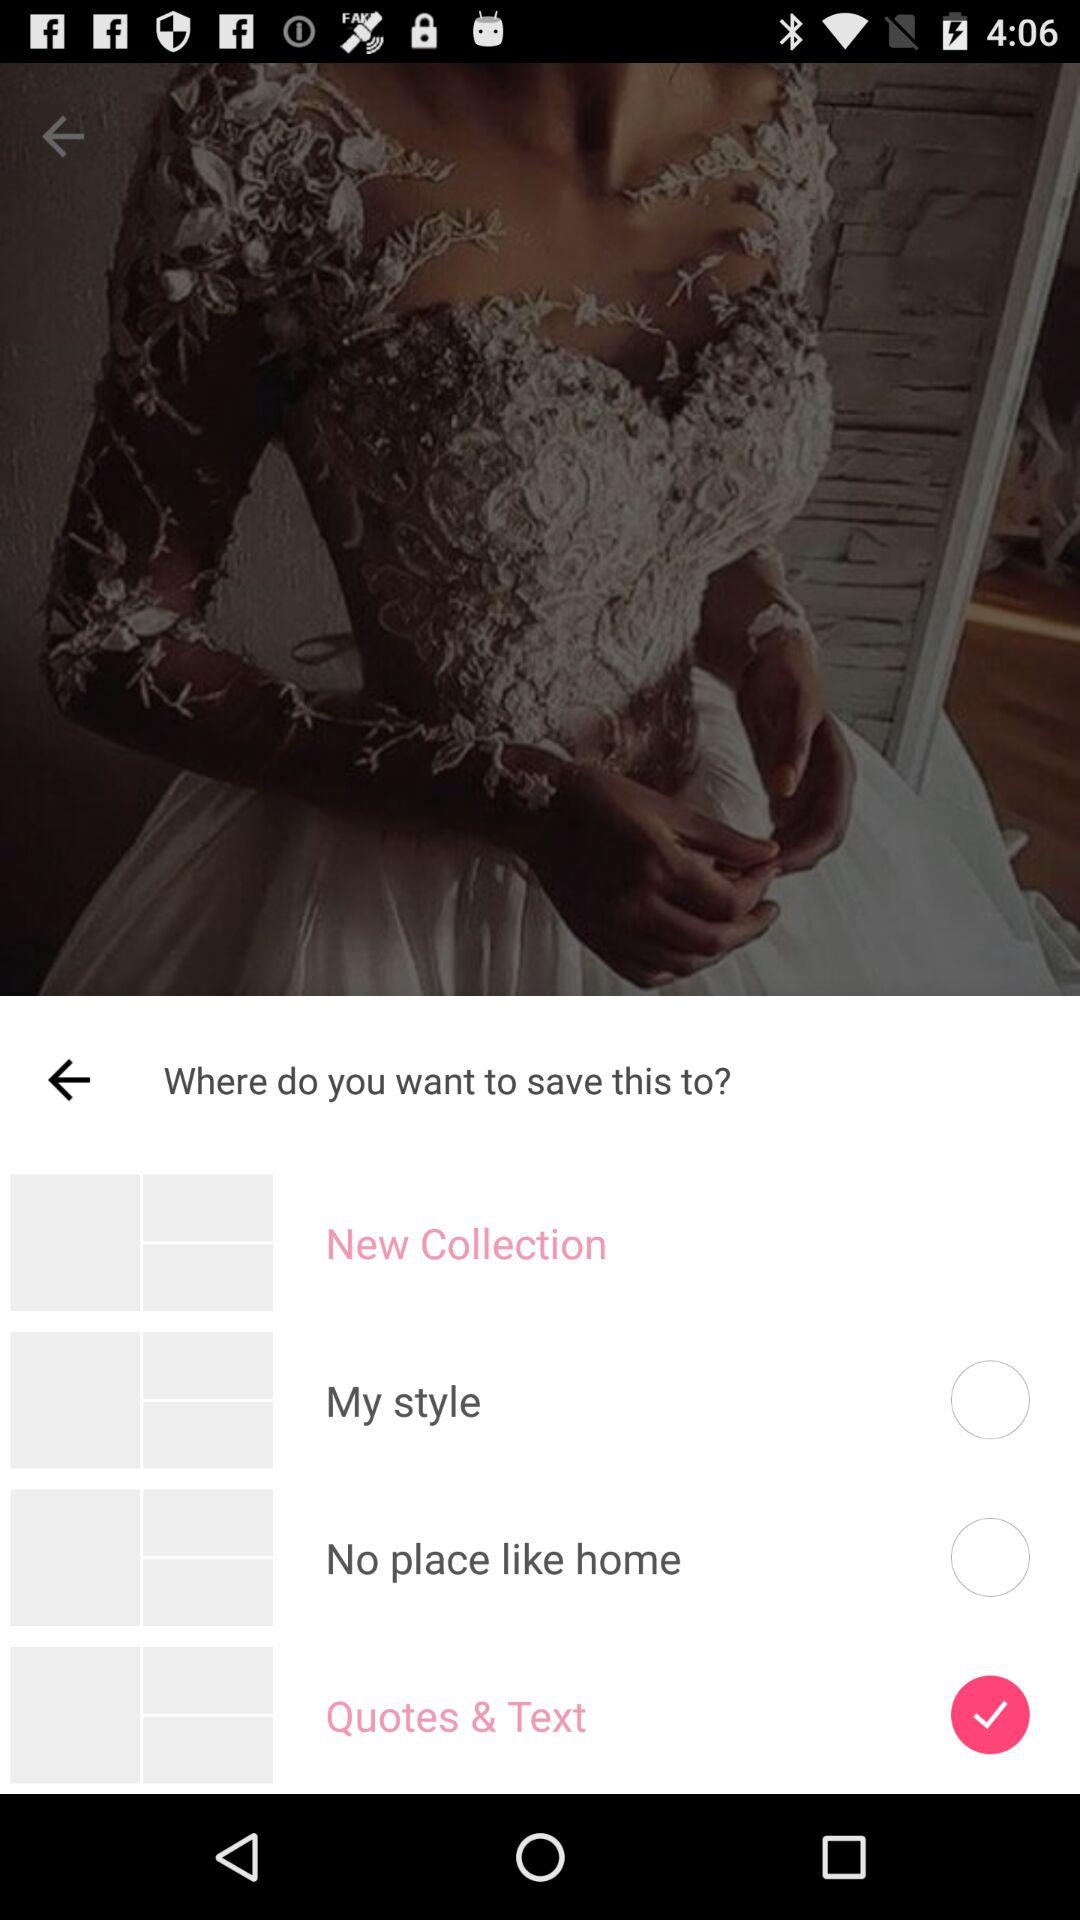Which option is selected to save the post? The option that is selected to save the post is "Quotes & Text". 